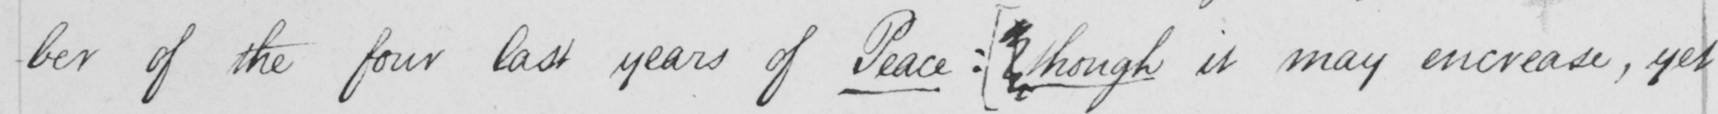What does this handwritten line say? -ber of the four last years of Peace :   [ though it may increase , yet 